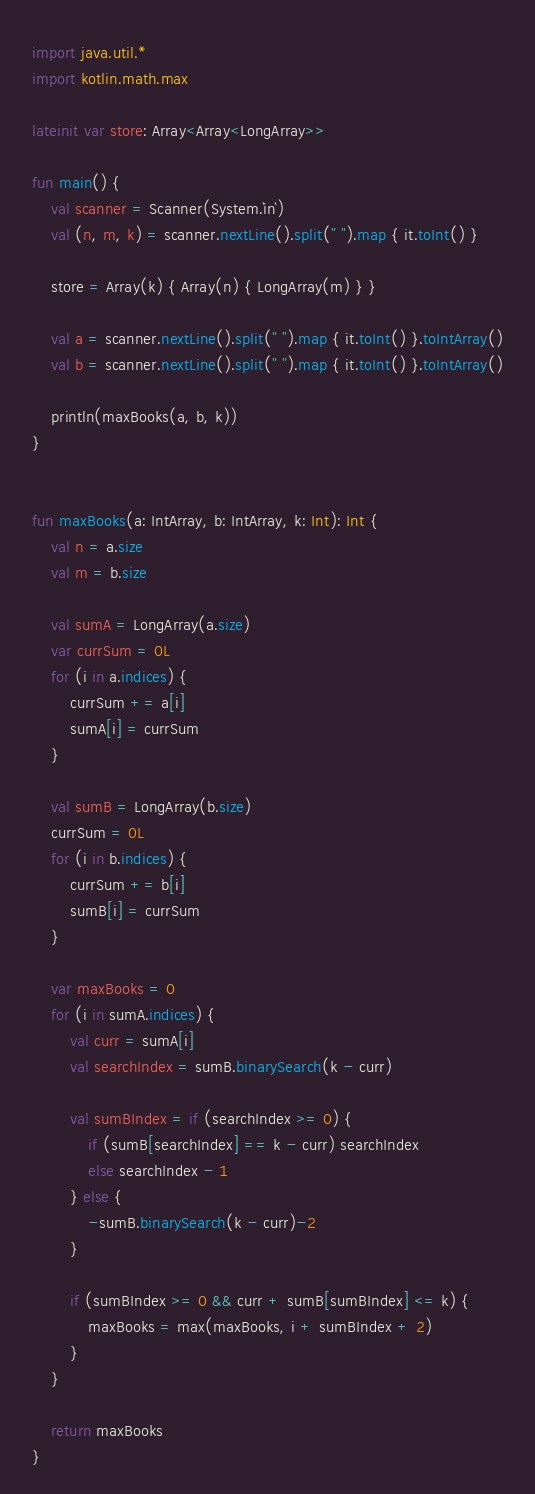Convert code to text. <code><loc_0><loc_0><loc_500><loc_500><_Kotlin_>import java.util.*
import kotlin.math.max

lateinit var store: Array<Array<LongArray>>

fun main() {
    val scanner = Scanner(System.`in`)
    val (n, m, k) = scanner.nextLine().split(" ").map { it.toInt() }

    store = Array(k) { Array(n) { LongArray(m) } }

    val a = scanner.nextLine().split(" ").map { it.toInt() }.toIntArray()
    val b = scanner.nextLine().split(" ").map { it.toInt() }.toIntArray()

    println(maxBooks(a, b, k))
}


fun maxBooks(a: IntArray, b: IntArray, k: Int): Int {
    val n = a.size
    val m = b.size

    val sumA = LongArray(a.size)
    var currSum = 0L
    for (i in a.indices) {
        currSum += a[i]
        sumA[i] = currSum
    }

    val sumB = LongArray(b.size)
    currSum = 0L
    for (i in b.indices) {
        currSum += b[i]
        sumB[i] = currSum
    }

    var maxBooks = 0
    for (i in sumA.indices) {
        val curr = sumA[i]
        val searchIndex = sumB.binarySearch(k - curr)

        val sumBIndex = if (searchIndex >= 0) {
            if (sumB[searchIndex] == k - curr) searchIndex
            else searchIndex - 1
        } else {
            -sumB.binarySearch(k - curr)-2
        }

        if (sumBIndex >= 0 && curr + sumB[sumBIndex] <= k) {
            maxBooks = max(maxBooks, i + sumBIndex + 2)
        }
    }

    return maxBooks
}</code> 